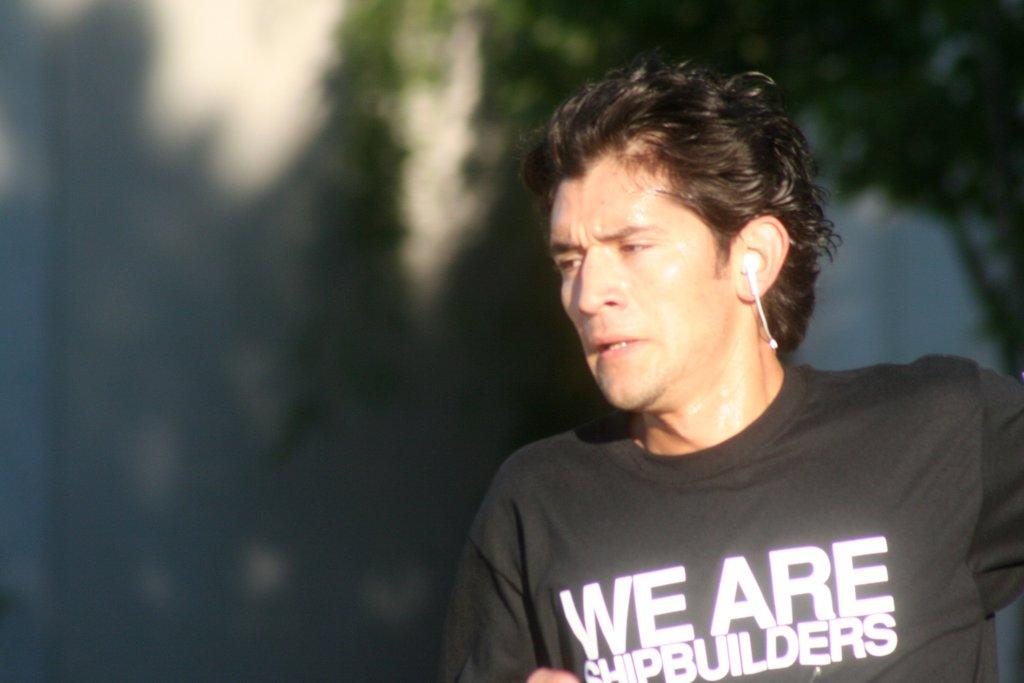What is located on the right side of the image? There is a man on the right side of the image. What can be seen in the man's ear? The man has a headset in his ear. What type of natural element is visible in the background of the image? There is a tree visible in the background of the image, although it is blurred. How many cents are visible on the man's forehead in the image? There are no cents visible on the man's forehead in the image. What actor is playing the role of the man in the image? The image does not depict a specific actor playing the role of the man; it is a photograph of an unidentified individual. 